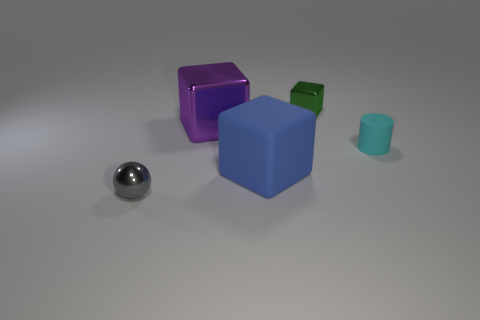Add 2 tiny gray metallic things. How many objects exist? 7 Subtract all cylinders. How many objects are left? 4 Subtract 0 blue cylinders. How many objects are left? 5 Subtract all large rubber things. Subtract all cyan rubber cylinders. How many objects are left? 3 Add 3 large purple metallic blocks. How many large purple metallic blocks are left? 4 Add 4 matte cylinders. How many matte cylinders exist? 5 